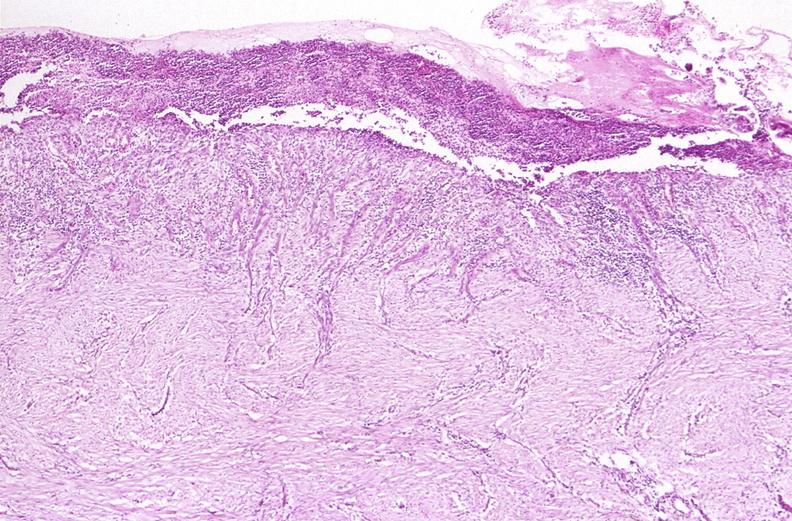where is this from?
Answer the question using a single word or phrase. Gastrointestinal system 